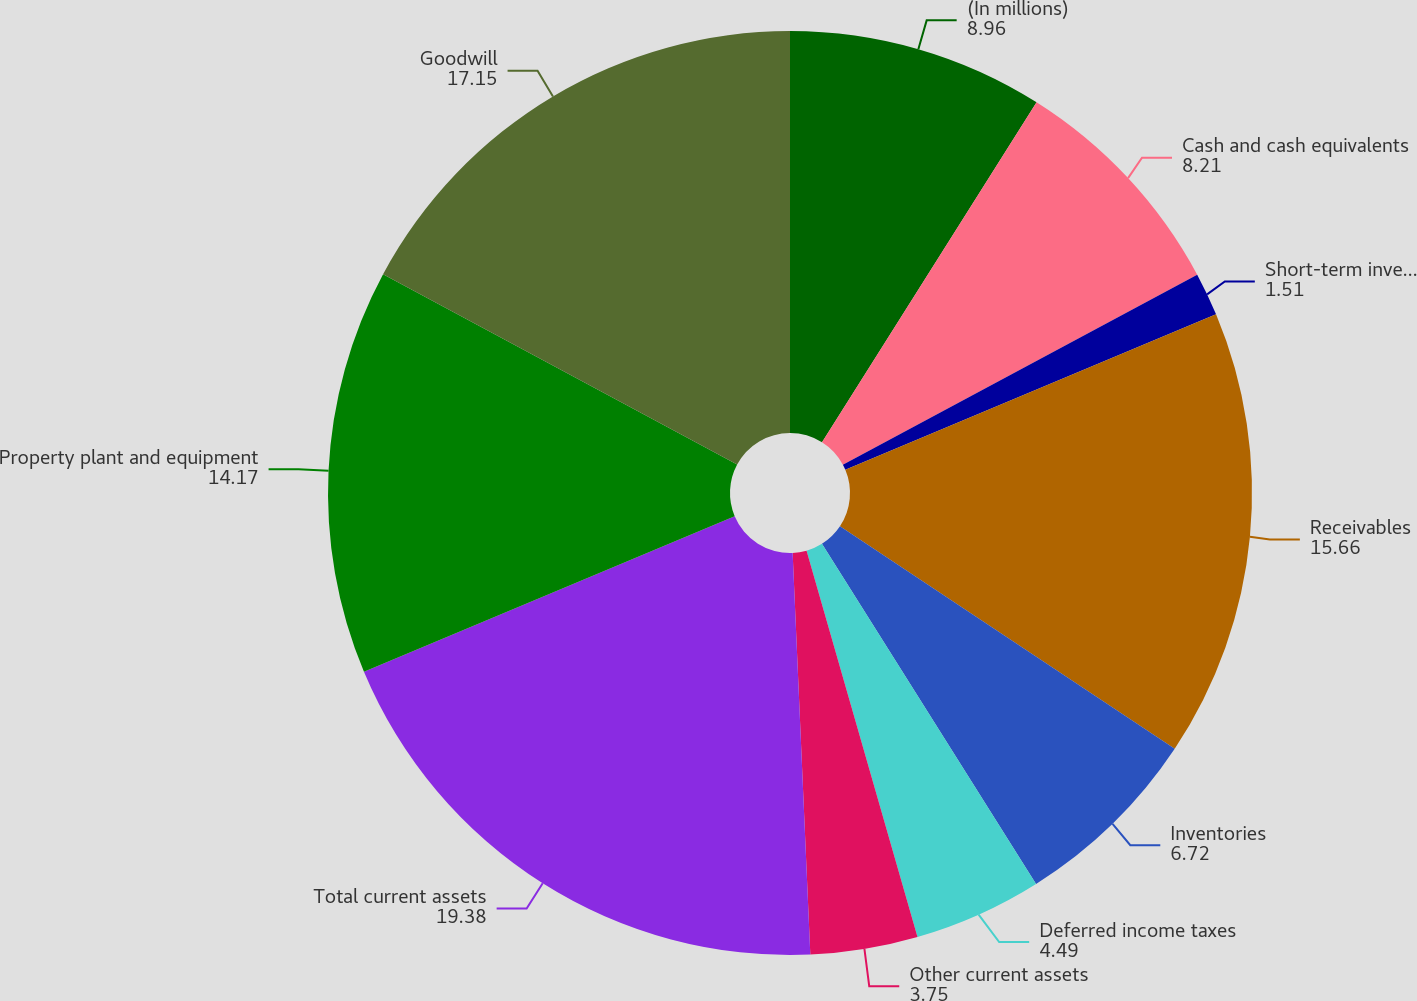<chart> <loc_0><loc_0><loc_500><loc_500><pie_chart><fcel>(In millions)<fcel>Cash and cash equivalents<fcel>Short-term investments<fcel>Receivables<fcel>Inventories<fcel>Deferred income taxes<fcel>Other current assets<fcel>Total current assets<fcel>Property plant and equipment<fcel>Goodwill<nl><fcel>8.96%<fcel>8.21%<fcel>1.51%<fcel>15.66%<fcel>6.72%<fcel>4.49%<fcel>3.75%<fcel>19.38%<fcel>14.17%<fcel>17.15%<nl></chart> 